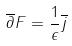<formula> <loc_0><loc_0><loc_500><loc_500>\overline { \partial } F = \frac { 1 } { \epsilon } \overline { j }</formula> 